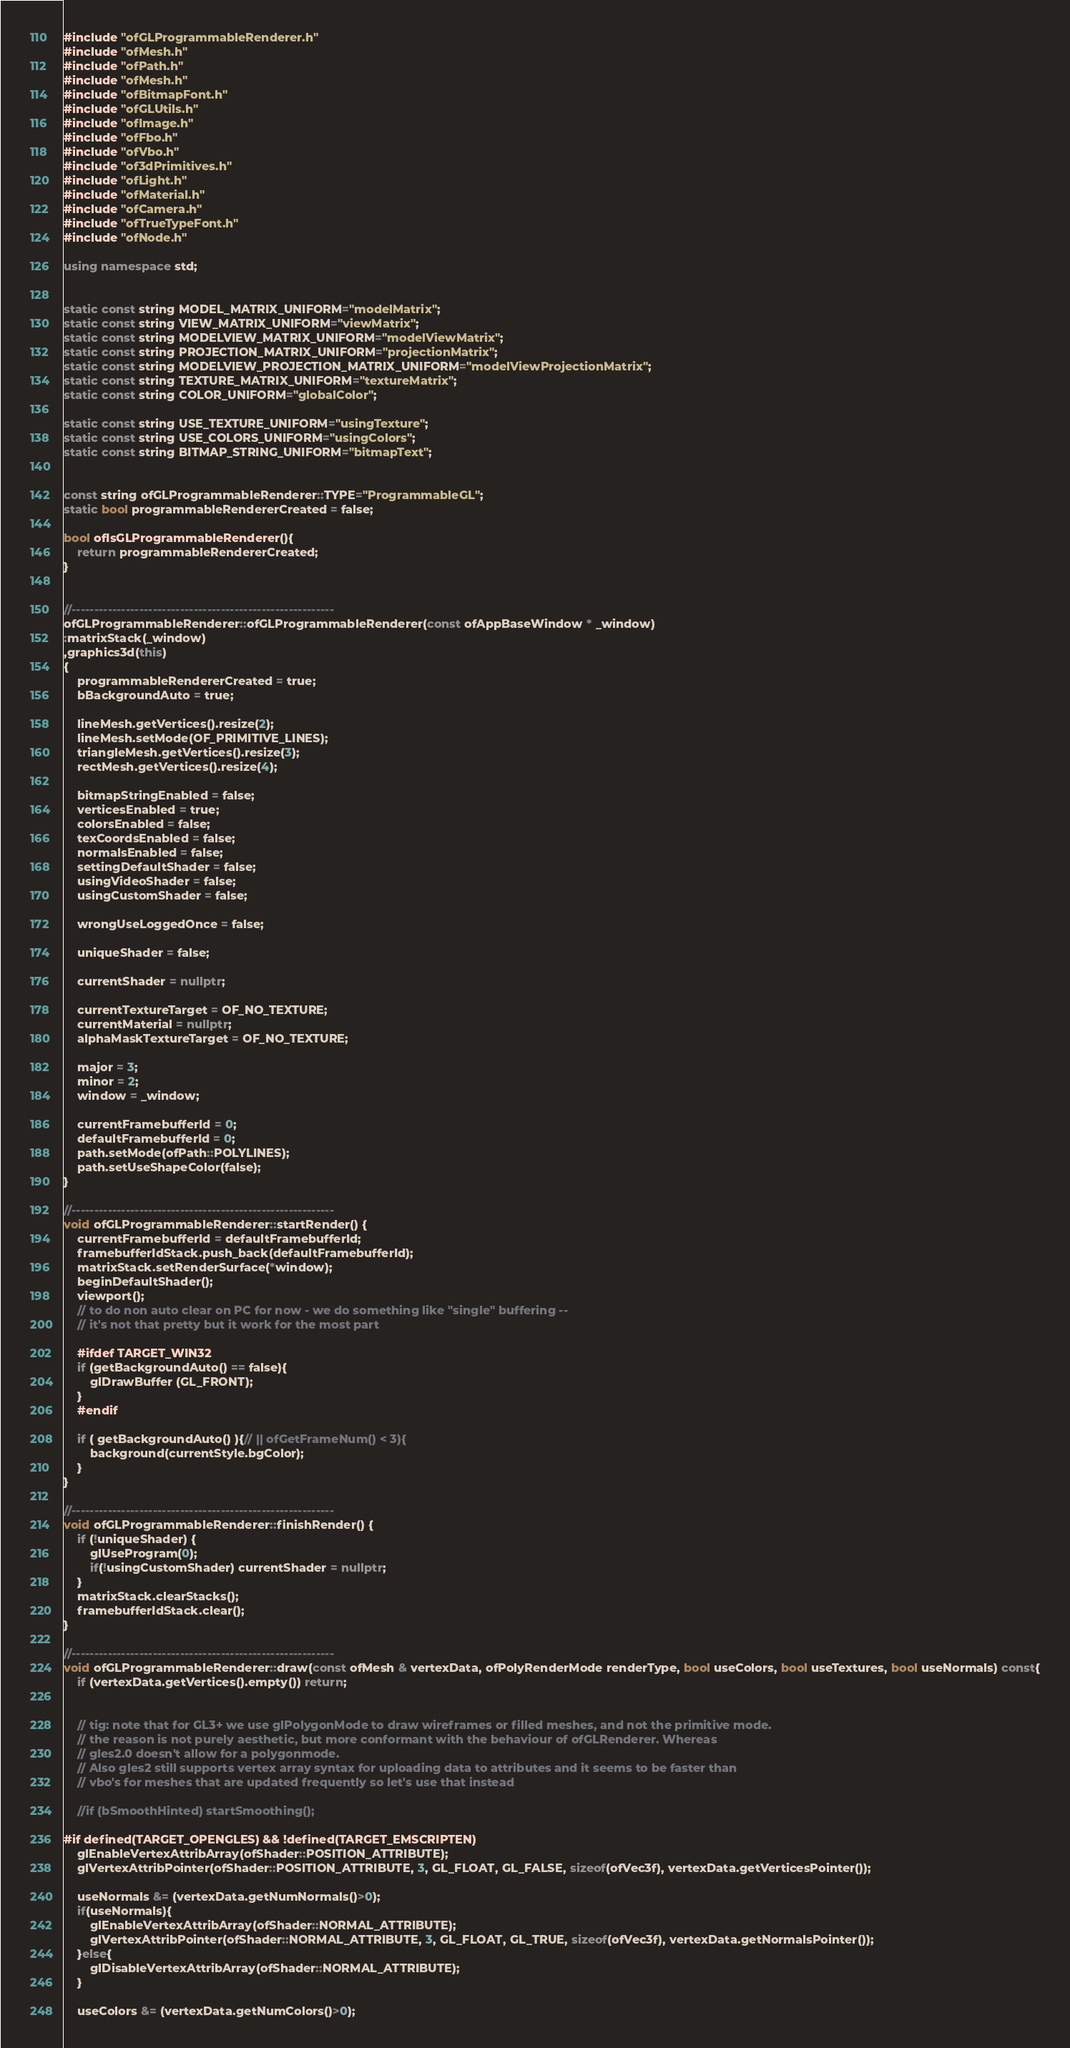Convert code to text. <code><loc_0><loc_0><loc_500><loc_500><_C++_>#include "ofGLProgrammableRenderer.h"
#include "ofMesh.h"
#include "ofPath.h"
#include "ofMesh.h"
#include "ofBitmapFont.h"
#include "ofGLUtils.h"
#include "ofImage.h"
#include "ofFbo.h"
#include "ofVbo.h"
#include "of3dPrimitives.h"
#include "ofLight.h"
#include "ofMaterial.h"
#include "ofCamera.h"
#include "ofTrueTypeFont.h"
#include "ofNode.h"

using namespace std;


static const string MODEL_MATRIX_UNIFORM="modelMatrix";
static const string VIEW_MATRIX_UNIFORM="viewMatrix";
static const string MODELVIEW_MATRIX_UNIFORM="modelViewMatrix";
static const string PROJECTION_MATRIX_UNIFORM="projectionMatrix";
static const string MODELVIEW_PROJECTION_MATRIX_UNIFORM="modelViewProjectionMatrix";
static const string TEXTURE_MATRIX_UNIFORM="textureMatrix";
static const string COLOR_UNIFORM="globalColor";

static const string USE_TEXTURE_UNIFORM="usingTexture";
static const string USE_COLORS_UNIFORM="usingColors";
static const string BITMAP_STRING_UNIFORM="bitmapText";


const string ofGLProgrammableRenderer::TYPE="ProgrammableGL";
static bool programmableRendererCreated = false;

bool ofIsGLProgrammableRenderer(){
	return programmableRendererCreated;
}


//----------------------------------------------------------
ofGLProgrammableRenderer::ofGLProgrammableRenderer(const ofAppBaseWindow * _window)
:matrixStack(_window)
,graphics3d(this)
{
	programmableRendererCreated = true;
	bBackgroundAuto = true;

	lineMesh.getVertices().resize(2);
	lineMesh.setMode(OF_PRIMITIVE_LINES);
	triangleMesh.getVertices().resize(3);
	rectMesh.getVertices().resize(4);

	bitmapStringEnabled = false;
    verticesEnabled = true;
    colorsEnabled = false;
    texCoordsEnabled = false;
    normalsEnabled = false;
	settingDefaultShader = false;
	usingVideoShader = false;
	usingCustomShader = false;

	wrongUseLoggedOnce = false;

	uniqueShader = false;

	currentShader = nullptr;

	currentTextureTarget = OF_NO_TEXTURE;
	currentMaterial = nullptr;
	alphaMaskTextureTarget = OF_NO_TEXTURE;

	major = 3;
	minor = 2;
	window = _window;

	currentFramebufferId = 0;
	defaultFramebufferId = 0;
	path.setMode(ofPath::POLYLINES);
    path.setUseShapeColor(false);
}

//----------------------------------------------------------
void ofGLProgrammableRenderer::startRender() {
	currentFramebufferId = defaultFramebufferId;
	framebufferIdStack.push_back(defaultFramebufferId);
	matrixStack.setRenderSurface(*window);
	beginDefaultShader();
	viewport();
    // to do non auto clear on PC for now - we do something like "single" buffering --
    // it's not that pretty but it work for the most part

    #ifdef TARGET_WIN32
    if (getBackgroundAuto() == false){
        glDrawBuffer (GL_FRONT);
    }
    #endif

	if ( getBackgroundAuto() ){// || ofGetFrameNum() < 3){
		background(currentStyle.bgColor);
	}
}

//----------------------------------------------------------
void ofGLProgrammableRenderer::finishRender() {
	if (!uniqueShader) {
		glUseProgram(0);
		if(!usingCustomShader) currentShader = nullptr;
	}
	matrixStack.clearStacks();
	framebufferIdStack.clear();
}

//----------------------------------------------------------
void ofGLProgrammableRenderer::draw(const ofMesh & vertexData, ofPolyRenderMode renderType, bool useColors, bool useTextures, bool useNormals) const{
	if (vertexData.getVertices().empty()) return;
	
	
	// tig: note that for GL3+ we use glPolygonMode to draw wireframes or filled meshes, and not the primitive mode.
	// the reason is not purely aesthetic, but more conformant with the behaviour of ofGLRenderer. Whereas
	// gles2.0 doesn't allow for a polygonmode.
	// Also gles2 still supports vertex array syntax for uploading data to attributes and it seems to be faster than
	// vbo's for meshes that are updated frequently so let's use that instead
	
	//if (bSmoothHinted) startSmoothing();

#if defined(TARGET_OPENGLES) && !defined(TARGET_EMSCRIPTEN)
	glEnableVertexAttribArray(ofShader::POSITION_ATTRIBUTE);
	glVertexAttribPointer(ofShader::POSITION_ATTRIBUTE, 3, GL_FLOAT, GL_FALSE, sizeof(ofVec3f), vertexData.getVerticesPointer());
	
	useNormals &= (vertexData.getNumNormals()>0);
	if(useNormals){
		glEnableVertexAttribArray(ofShader::NORMAL_ATTRIBUTE);
		glVertexAttribPointer(ofShader::NORMAL_ATTRIBUTE, 3, GL_FLOAT, GL_TRUE, sizeof(ofVec3f), vertexData.getNormalsPointer());
	}else{
		glDisableVertexAttribArray(ofShader::NORMAL_ATTRIBUTE);
	}
	
	useColors &= (vertexData.getNumColors()>0);</code> 